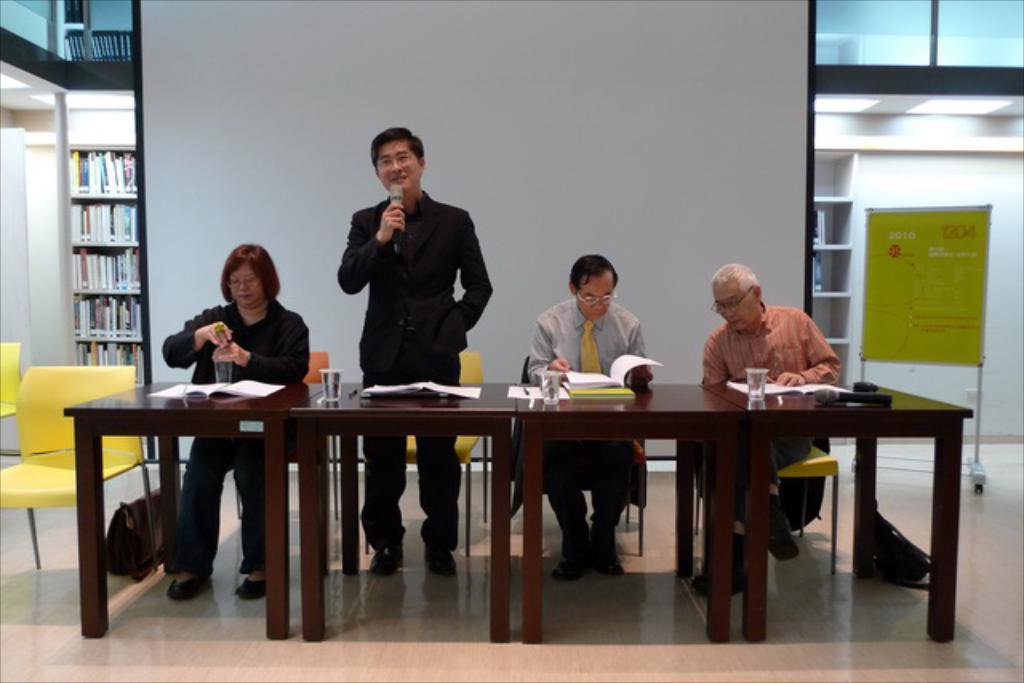Please provide a concise description of this image. This person wore black suit and holding a mic. These three persons are sitting on a chair. On this table there are glasses, mic and books. This rack is filled with books. This is yellow chair. Far there is a banner with stand. Beside this table there is a bag. 